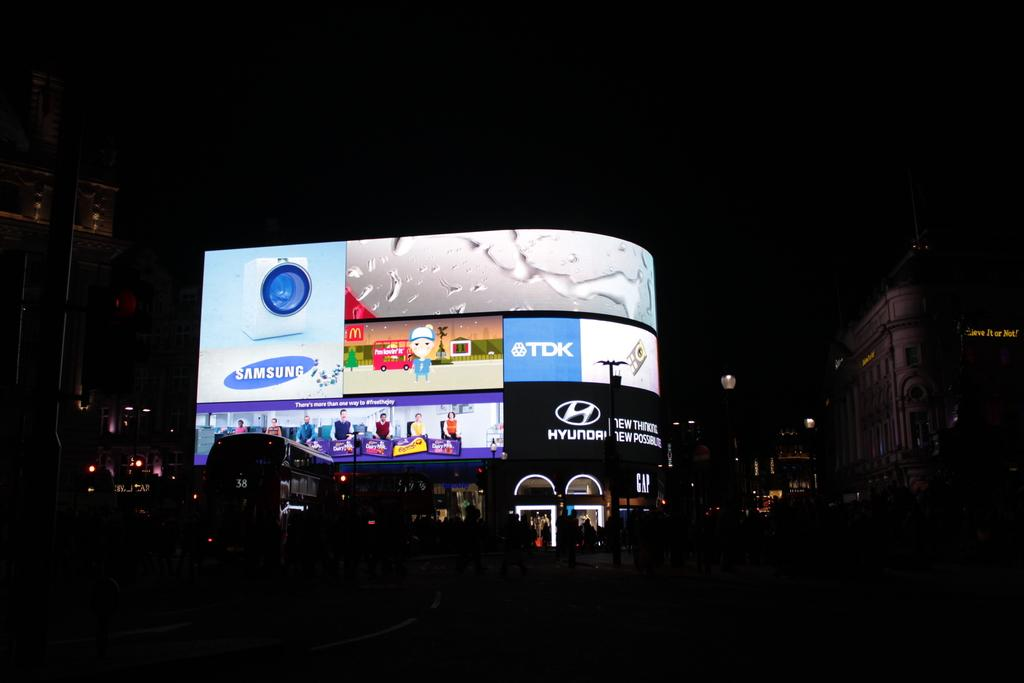<image>
Write a terse but informative summary of the picture. a tv screen displays an ad for samsung and TDK 